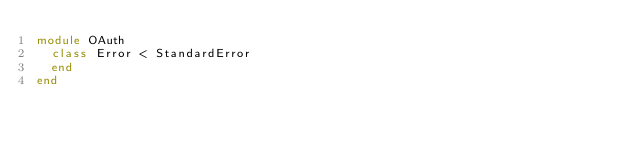<code> <loc_0><loc_0><loc_500><loc_500><_Ruby_>module OAuth
  class Error < StandardError
  end
end
</code> 